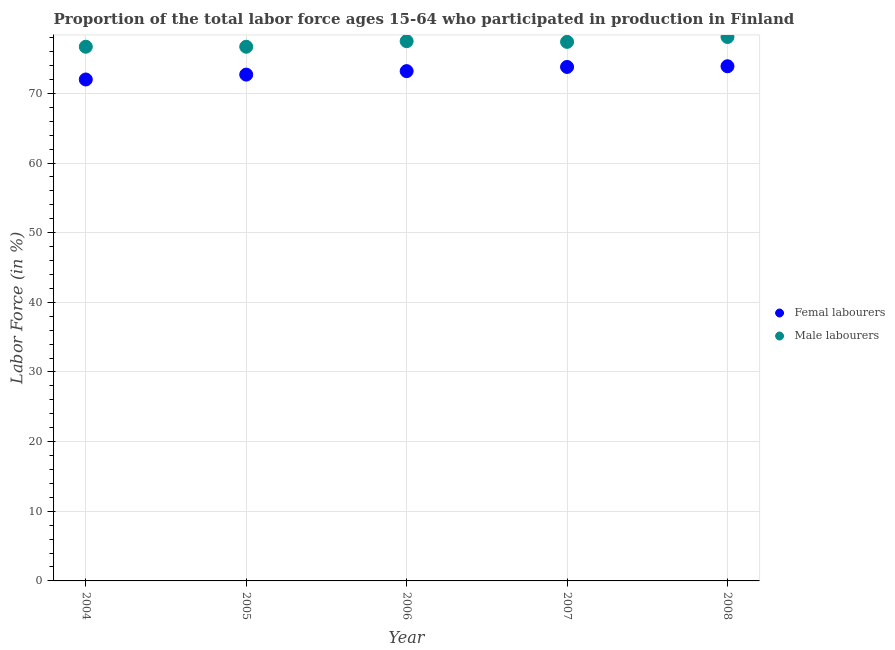How many different coloured dotlines are there?
Offer a very short reply. 2. What is the percentage of male labour force in 2004?
Offer a terse response. 76.7. Across all years, what is the maximum percentage of female labor force?
Your answer should be very brief. 73.9. Across all years, what is the minimum percentage of female labor force?
Your answer should be very brief. 72. In which year was the percentage of male labour force maximum?
Provide a succinct answer. 2008. What is the total percentage of male labour force in the graph?
Offer a terse response. 386.4. What is the difference between the percentage of male labour force in 2006 and that in 2007?
Offer a terse response. 0.1. What is the difference between the percentage of male labour force in 2006 and the percentage of female labor force in 2004?
Offer a terse response. 5.5. What is the average percentage of male labour force per year?
Provide a succinct answer. 77.28. In the year 2006, what is the difference between the percentage of male labour force and percentage of female labor force?
Your response must be concise. 4.3. What is the ratio of the percentage of male labour force in 2006 to that in 2007?
Provide a succinct answer. 1. Is the difference between the percentage of male labour force in 2005 and 2008 greater than the difference between the percentage of female labor force in 2005 and 2008?
Make the answer very short. No. What is the difference between the highest and the second highest percentage of male labour force?
Offer a terse response. 0.6. What is the difference between the highest and the lowest percentage of female labor force?
Your answer should be very brief. 1.9. In how many years, is the percentage of female labor force greater than the average percentage of female labor force taken over all years?
Your answer should be very brief. 3. Is the sum of the percentage of male labour force in 2004 and 2006 greater than the maximum percentage of female labor force across all years?
Provide a succinct answer. Yes. Does the percentage of female labor force monotonically increase over the years?
Provide a short and direct response. Yes. Is the percentage of female labor force strictly less than the percentage of male labour force over the years?
Offer a very short reply. Yes. Does the graph contain any zero values?
Offer a terse response. No. Does the graph contain grids?
Offer a terse response. Yes. What is the title of the graph?
Make the answer very short. Proportion of the total labor force ages 15-64 who participated in production in Finland. What is the label or title of the Y-axis?
Your answer should be compact. Labor Force (in %). What is the Labor Force (in %) of Femal labourers in 2004?
Your answer should be very brief. 72. What is the Labor Force (in %) of Male labourers in 2004?
Give a very brief answer. 76.7. What is the Labor Force (in %) in Femal labourers in 2005?
Your answer should be very brief. 72.7. What is the Labor Force (in %) in Male labourers in 2005?
Your response must be concise. 76.7. What is the Labor Force (in %) in Femal labourers in 2006?
Make the answer very short. 73.2. What is the Labor Force (in %) in Male labourers in 2006?
Provide a succinct answer. 77.5. What is the Labor Force (in %) of Femal labourers in 2007?
Make the answer very short. 73.8. What is the Labor Force (in %) in Male labourers in 2007?
Your response must be concise. 77.4. What is the Labor Force (in %) of Femal labourers in 2008?
Provide a succinct answer. 73.9. What is the Labor Force (in %) in Male labourers in 2008?
Provide a short and direct response. 78.1. Across all years, what is the maximum Labor Force (in %) of Femal labourers?
Provide a short and direct response. 73.9. Across all years, what is the maximum Labor Force (in %) of Male labourers?
Your answer should be very brief. 78.1. Across all years, what is the minimum Labor Force (in %) in Male labourers?
Offer a terse response. 76.7. What is the total Labor Force (in %) in Femal labourers in the graph?
Provide a short and direct response. 365.6. What is the total Labor Force (in %) in Male labourers in the graph?
Keep it short and to the point. 386.4. What is the difference between the Labor Force (in %) of Femal labourers in 2004 and that in 2006?
Give a very brief answer. -1.2. What is the difference between the Labor Force (in %) of Male labourers in 2004 and that in 2006?
Offer a very short reply. -0.8. What is the difference between the Labor Force (in %) in Male labourers in 2004 and that in 2008?
Your answer should be compact. -1.4. What is the difference between the Labor Force (in %) of Male labourers in 2005 and that in 2006?
Your response must be concise. -0.8. What is the difference between the Labor Force (in %) in Femal labourers in 2005 and that in 2008?
Provide a short and direct response. -1.2. What is the difference between the Labor Force (in %) of Male labourers in 2005 and that in 2008?
Keep it short and to the point. -1.4. What is the difference between the Labor Force (in %) of Femal labourers in 2004 and the Labor Force (in %) of Male labourers in 2006?
Give a very brief answer. -5.5. What is the difference between the Labor Force (in %) of Femal labourers in 2004 and the Labor Force (in %) of Male labourers in 2007?
Offer a very short reply. -5.4. What is the difference between the Labor Force (in %) of Femal labourers in 2004 and the Labor Force (in %) of Male labourers in 2008?
Ensure brevity in your answer.  -6.1. What is the difference between the Labor Force (in %) of Femal labourers in 2005 and the Labor Force (in %) of Male labourers in 2006?
Offer a very short reply. -4.8. What is the difference between the Labor Force (in %) in Femal labourers in 2005 and the Labor Force (in %) in Male labourers in 2007?
Your answer should be very brief. -4.7. What is the difference between the Labor Force (in %) in Femal labourers in 2006 and the Labor Force (in %) in Male labourers in 2007?
Your answer should be very brief. -4.2. What is the difference between the Labor Force (in %) in Femal labourers in 2007 and the Labor Force (in %) in Male labourers in 2008?
Keep it short and to the point. -4.3. What is the average Labor Force (in %) of Femal labourers per year?
Give a very brief answer. 73.12. What is the average Labor Force (in %) of Male labourers per year?
Make the answer very short. 77.28. In the year 2004, what is the difference between the Labor Force (in %) of Femal labourers and Labor Force (in %) of Male labourers?
Provide a short and direct response. -4.7. What is the ratio of the Labor Force (in %) of Femal labourers in 2004 to that in 2006?
Make the answer very short. 0.98. What is the ratio of the Labor Force (in %) in Male labourers in 2004 to that in 2006?
Make the answer very short. 0.99. What is the ratio of the Labor Force (in %) in Femal labourers in 2004 to that in 2007?
Your answer should be very brief. 0.98. What is the ratio of the Labor Force (in %) in Femal labourers in 2004 to that in 2008?
Offer a very short reply. 0.97. What is the ratio of the Labor Force (in %) of Male labourers in 2004 to that in 2008?
Offer a terse response. 0.98. What is the ratio of the Labor Force (in %) in Femal labourers in 2005 to that in 2007?
Give a very brief answer. 0.99. What is the ratio of the Labor Force (in %) in Femal labourers in 2005 to that in 2008?
Provide a succinct answer. 0.98. What is the ratio of the Labor Force (in %) of Male labourers in 2005 to that in 2008?
Offer a very short reply. 0.98. What is the ratio of the Labor Force (in %) of Femal labourers in 2006 to that in 2007?
Make the answer very short. 0.99. What is the ratio of the Labor Force (in %) in Male labourers in 2006 to that in 2008?
Give a very brief answer. 0.99. What is the ratio of the Labor Force (in %) in Femal labourers in 2007 to that in 2008?
Your response must be concise. 1. What is the ratio of the Labor Force (in %) in Male labourers in 2007 to that in 2008?
Your answer should be very brief. 0.99. What is the difference between the highest and the second highest Labor Force (in %) of Male labourers?
Your answer should be very brief. 0.6. What is the difference between the highest and the lowest Labor Force (in %) in Male labourers?
Provide a succinct answer. 1.4. 